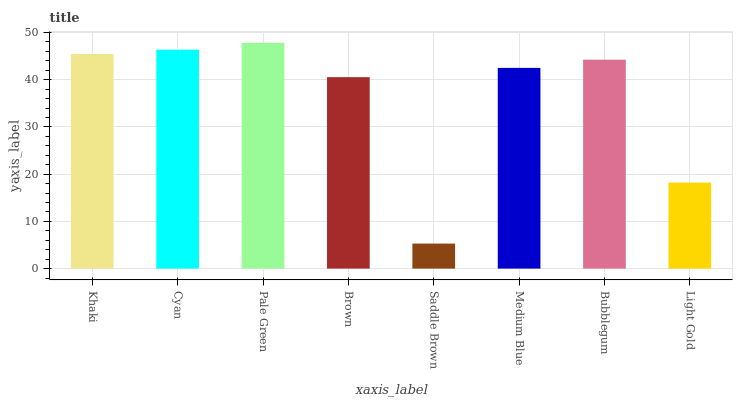Is Cyan the minimum?
Answer yes or no. No. Is Cyan the maximum?
Answer yes or no. No. Is Cyan greater than Khaki?
Answer yes or no. Yes. Is Khaki less than Cyan?
Answer yes or no. Yes. Is Khaki greater than Cyan?
Answer yes or no. No. Is Cyan less than Khaki?
Answer yes or no. No. Is Bubblegum the high median?
Answer yes or no. Yes. Is Medium Blue the low median?
Answer yes or no. Yes. Is Light Gold the high median?
Answer yes or no. No. Is Cyan the low median?
Answer yes or no. No. 